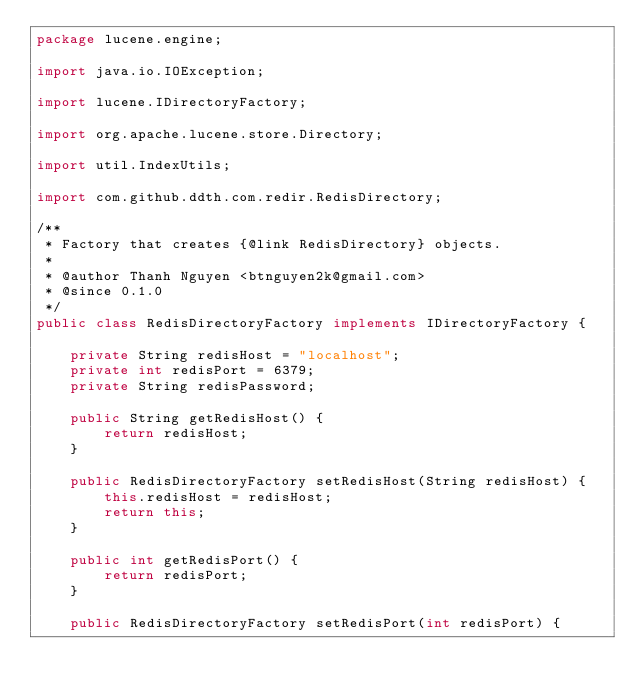Convert code to text. <code><loc_0><loc_0><loc_500><loc_500><_Java_>package lucene.engine;

import java.io.IOException;

import lucene.IDirectoryFactory;

import org.apache.lucene.store.Directory;

import util.IndexUtils;

import com.github.ddth.com.redir.RedisDirectory;

/**
 * Factory that creates {@link RedisDirectory} objects.
 * 
 * @author Thanh Nguyen <btnguyen2k@gmail.com>
 * @since 0.1.0
 */
public class RedisDirectoryFactory implements IDirectoryFactory {

    private String redisHost = "localhost";
    private int redisPort = 6379;
    private String redisPassword;

    public String getRedisHost() {
        return redisHost;
    }

    public RedisDirectoryFactory setRedisHost(String redisHost) {
        this.redisHost = redisHost;
        return this;
    }

    public int getRedisPort() {
        return redisPort;
    }

    public RedisDirectoryFactory setRedisPort(int redisPort) {</code> 